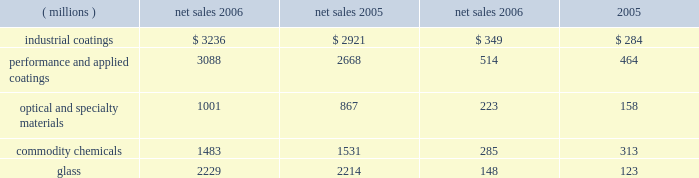Management 2019s discussion and analysis value of the company 2019s obligation relating to asbestos claims under the ppg settlement arrangement .
The legal settlements net of insurance included aftertax charges of $ 80 million for the marvin legal settlement , net of insurance recoveries of $ 11 million , and $ 37 million for the impact of the federal glass class action antitrust legal settlement .
Results of reportable business segments net sales segment income ( millions ) 2006 2005 2006 2005 .
Industrial coatings sales increased $ 315 million or 11% ( 11 % ) in 2006 .
Sales increased 4% ( 4 % ) due to acquisitions , 4% ( 4 % ) due to increased volumes in the automotive , industrial and packaging coatings operating segments , 2% ( 2 % ) due to higher selling prices , particularly in the industrial and packaging coatings businesses and 1% ( 1 % ) due to the positive effects of foreign currency translation .
Segment income increased $ 65 million in 2006 .
The increase in segment income was primarily due to the impact of increased sales volume , lower overhead and manufacturing costs , and the impact of acquisitions .
Segment income was reduced by the adverse impact of inflation , which was substantially offset by higher selling prices .
Performance and applied coatings sales increased $ 420 million or 16% ( 16 % ) in 2006 .
Sales increased 8% ( 8 % ) due to acquisitions , 4% ( 4 % ) due to higher selling prices in the refinish , aerospace and architectural coatings operating segments , 3% ( 3 % ) due to increased volumes in our aerospace and architectural coatings businesses and 1% ( 1 % ) due to the positive effects of foreign currency translation .
Segment income increased $ 50 million in 2006 .
The increase in segment income was primarily due to the impact of increased sales volume and higher selling prices , which more than offset the impact of inflation .
Segment income was reduced by increased overhead costs to support growth in our architectural coatings business .
Optical and specialty materials sales increased $ 134 million or 15% ( 15 % ) in 2006 .
Sales increased 10% ( 10 % ) due to higher volumes , particularly in optical products and fine chemicals and 5% ( 5 % ) due to acquisitions in our optical products business .
Segment income increased $ 65 million in 2006 .
The absence of the 2005 charge for an asset impairment in our fine chemicals business increased segment income by $ 27 million .
The remaining $ 38 million increase in segment income was primarily due to increased volumes , lower manufacturing costs , and the absence of the 2005 hurricane costs of $ 3 million , net of 2006 insurance recoveries , which were only partially offset by increased overhead costs in our optical products business to support growth and the negative impact of inflation .
Commodity chemicals sales decreased $ 48 million or 3% ( 3 % ) in 2006 .
Sales decreased 4% ( 4 % ) due to lower chlor-alkali volumes and increased 1% ( 1 % ) due to higher selling prices .
Segment income decreased $ 28 million in 2006 .
The year- over-year decline in segment income was due primarily to lower sales volumes and higher manufacturing costs associated with reduced production levels .
The absence of the 2005 charges for direct costs related to hurricanes increased segment income by $ 29 million .
The impact of higher selling prices ; lower inflation , primarily natural gas costs , and an insurance recovery of $ 10 million related to the 2005 hurricane losses also increased segment income in 2006 .
Our fourth-quarter chlor-alkali sales volumes and earnings were negatively impacted by production outages at several customers over the last two months of 2006 .
It is uncertain when some of these customers will return to a normal level of production which may impact the sales and earnings of our chlor-alkali business in early 2007 .
Glass sales increased $ 15 million or 1% ( 1 % ) in 2006 .
Sales increased 1% ( 1 % ) due to improved volumes resulting from a combination of organic growth and an acquisition .
A slight positive impact on sales due to foreign currency translation offset a slight decline in pricing .
Volumes increased in the performance glazings , automotive replacement glass and services and fiber glass businesses .
Automotive oem glass volume declined during 2006 .
Pricing was also up in performance glazings , but declined in the other glass businesses .
Segment income increased $ 25 million in 2006 .
This increase in segment income was primarily the result of higher equity earnings from our asian fiber glass joint ventures , higher royalty income and lower manufacturing and natural gas costs , which more than offset the negative impacts of higher inflation , lower margin mix of sales and reduced selling prices .
Our fiber glass operating segment made progress during 2006 in achieving our multi-year plan to improve profitability and cash flow .
A transformation of our supply chain , which includes production of a more focused product mix at each manufacturing plant , manufacturing cost reduction initiatives and improved equity earnings from our asian joint ventures are the primary focus and represent the critical success factors in this plan .
During 2006 , our new joint venture in china started producing high labor content fiber glass reinforcement products , which will allow us to refocus our u.s .
Production capacity on higher margin , direct process products .
The 2006 earnings improvement by our fiber glass operating segment accounted for the bulk of the 2006 improvement in the glass reportable business segment income .
20 2006 ppg annual report and form 10-k 4282_txt .
The 2005 charge for asset impairments in the optical and specialty materials segment represented what percent of pre-impairment earnings for the segment? 
Computations: (27 / (27 + 158))
Answer: 0.14595. 